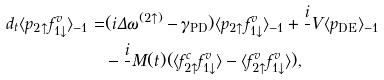<formula> <loc_0><loc_0><loc_500><loc_500>d _ { t } \langle p _ { 2 \uparrow } f ^ { v } _ { 1 \downarrow } \rangle _ { - 1 } = & ( i \Delta \omega ^ { ( 2 \uparrow ) } - \gamma _ { \text {PD} } ) \langle p _ { 2 \uparrow } f ^ { v } _ { 1 \downarrow } \rangle _ { - 1 } + \frac { i } { } V \langle p _ { \text {DE} } \rangle _ { - 1 } \\ & - \frac { i } { } M ( t ) ( \langle f _ { 2 \uparrow } ^ { c } f ^ { v } _ { 1 \downarrow } \rangle - \langle f _ { 2 \uparrow } ^ { v } f ^ { v } _ { 1 \downarrow } \rangle ) ,</formula> 